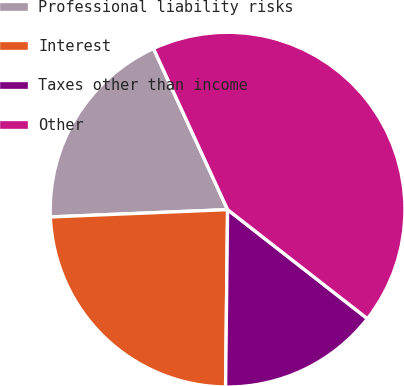Convert chart. <chart><loc_0><loc_0><loc_500><loc_500><pie_chart><fcel>Professional liability risks<fcel>Interest<fcel>Taxes other than income<fcel>Other<nl><fcel>18.8%<fcel>24.16%<fcel>14.64%<fcel>42.4%<nl></chart> 